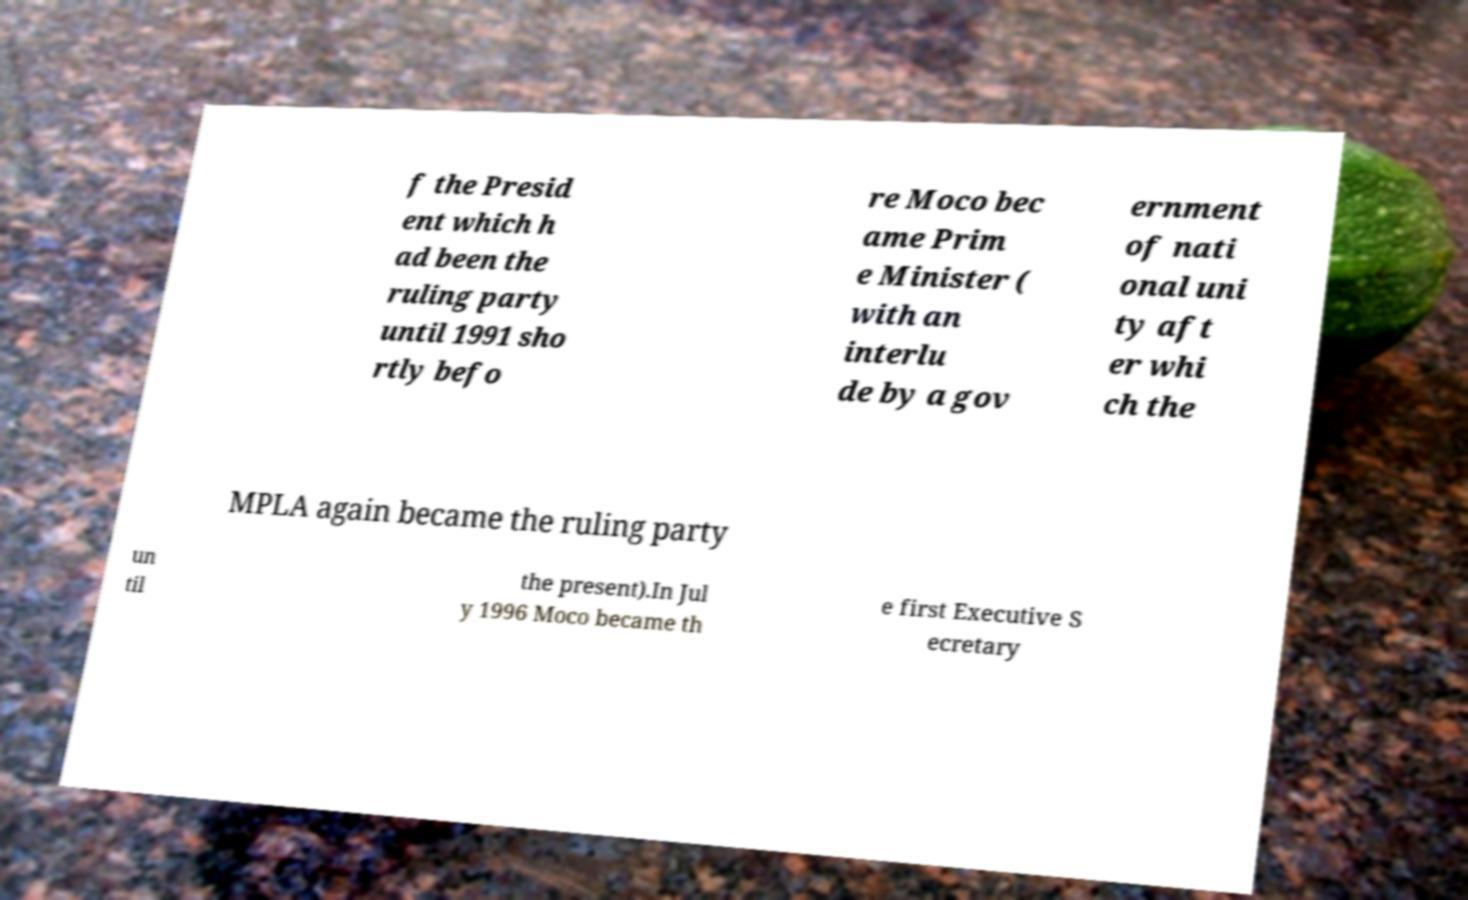Can you read and provide the text displayed in the image?This photo seems to have some interesting text. Can you extract and type it out for me? f the Presid ent which h ad been the ruling party until 1991 sho rtly befo re Moco bec ame Prim e Minister ( with an interlu de by a gov ernment of nati onal uni ty aft er whi ch the MPLA again became the ruling party un til the present).In Jul y 1996 Moco became th e first Executive S ecretary 